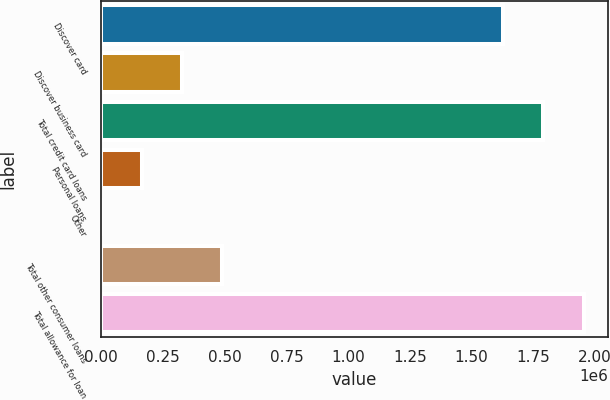Convert chart. <chart><loc_0><loc_0><loc_500><loc_500><bar_chart><fcel>Discover card<fcel>Discover business card<fcel>Total credit card loans<fcel>Personal loans<fcel>Other<fcel>Total other consumer loans<fcel>Total allowance for loan<nl><fcel>1.62732e+06<fcel>326920<fcel>1.79049e+06<fcel>163748<fcel>577<fcel>490091<fcel>1.95366e+06<nl></chart> 